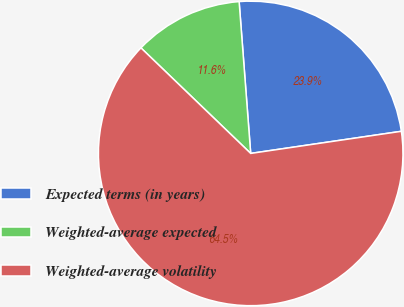Convert chart. <chart><loc_0><loc_0><loc_500><loc_500><pie_chart><fcel>Expected terms (in years)<fcel>Weighted-average expected<fcel>Weighted-average volatility<nl><fcel>23.89%<fcel>11.6%<fcel>64.51%<nl></chart> 